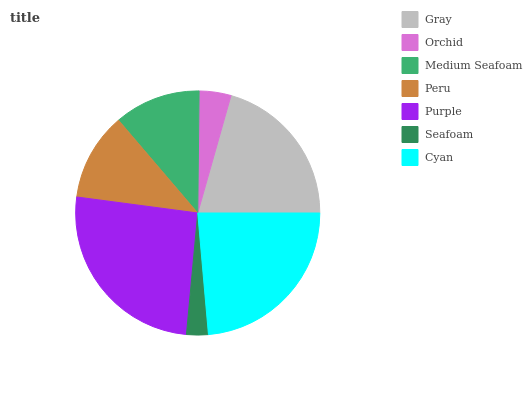Is Seafoam the minimum?
Answer yes or no. Yes. Is Purple the maximum?
Answer yes or no. Yes. Is Orchid the minimum?
Answer yes or no. No. Is Orchid the maximum?
Answer yes or no. No. Is Gray greater than Orchid?
Answer yes or no. Yes. Is Orchid less than Gray?
Answer yes or no. Yes. Is Orchid greater than Gray?
Answer yes or no. No. Is Gray less than Orchid?
Answer yes or no. No. Is Peru the high median?
Answer yes or no. Yes. Is Peru the low median?
Answer yes or no. Yes. Is Purple the high median?
Answer yes or no. No. Is Medium Seafoam the low median?
Answer yes or no. No. 